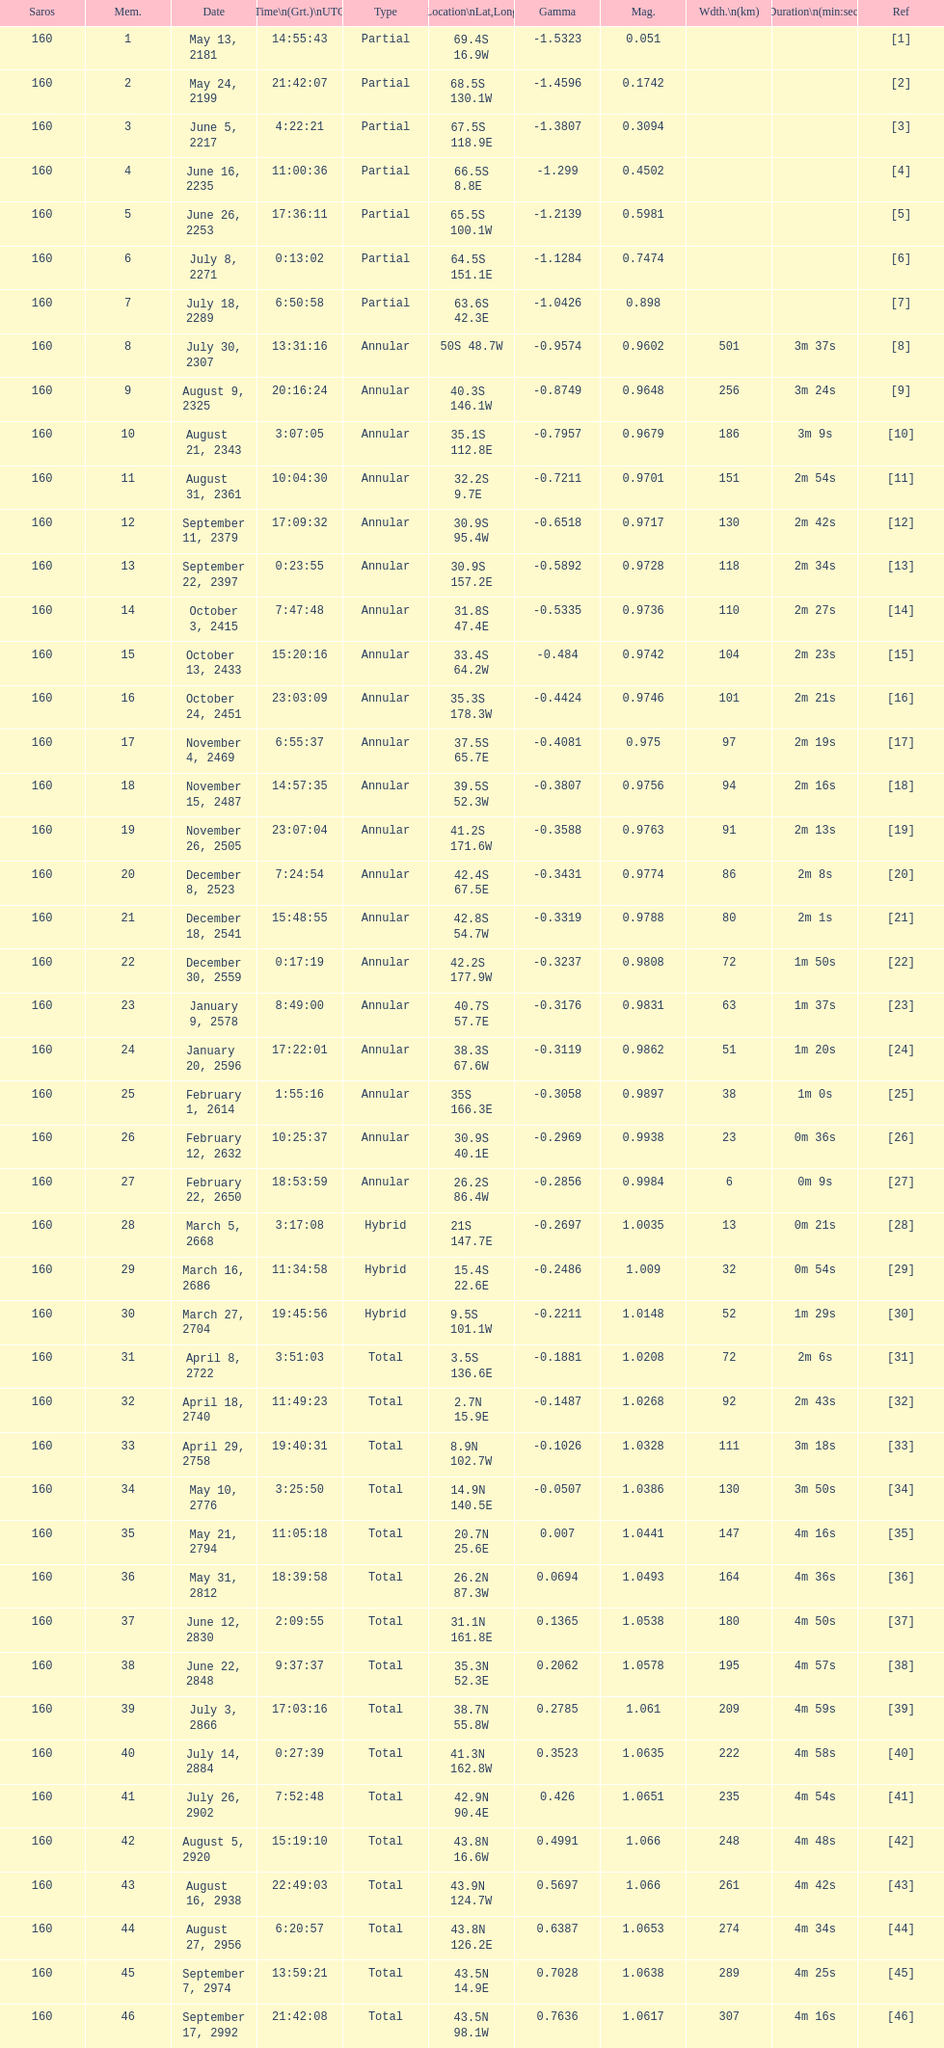What is the preceding occurrence for the saros on october 3, 2415? 7:47:48. 